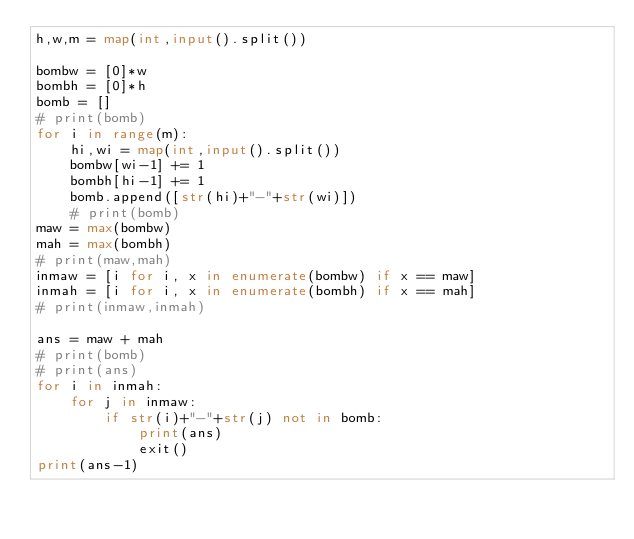<code> <loc_0><loc_0><loc_500><loc_500><_Python_>h,w,m = map(int,input().split())

bombw = [0]*w
bombh = [0]*h
bomb = []
# print(bomb)
for i in range(m):
    hi,wi = map(int,input().split())
    bombw[wi-1] += 1
    bombh[hi-1] += 1
    bomb.append([str(hi)+"-"+str(wi)])
    # print(bomb)
maw = max(bombw)
mah = max(bombh)
# print(maw,mah)
inmaw = [i for i, x in enumerate(bombw) if x == maw]
inmah = [i for i, x in enumerate(bombh) if x == mah]
# print(inmaw,inmah)

ans = maw + mah
# print(bomb)
# print(ans)
for i in inmah:
    for j in inmaw:
        if str(i)+"-"+str(j) not in bomb:
            print(ans)
            exit()
print(ans-1)
</code> 